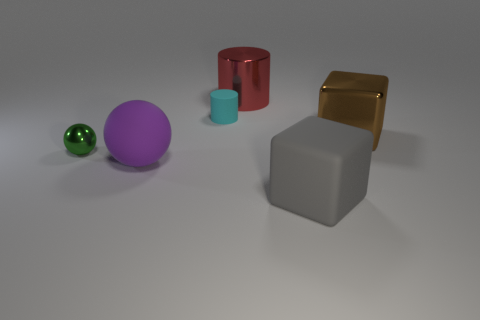Add 4 small gray rubber cylinders. How many objects exist? 10 Subtract all balls. How many objects are left? 4 Subtract all tiny cyan objects. Subtract all large brown metal cubes. How many objects are left? 4 Add 5 big shiny cubes. How many big shiny cubes are left? 6 Add 3 tiny metallic things. How many tiny metallic things exist? 4 Subtract 0 blue blocks. How many objects are left? 6 